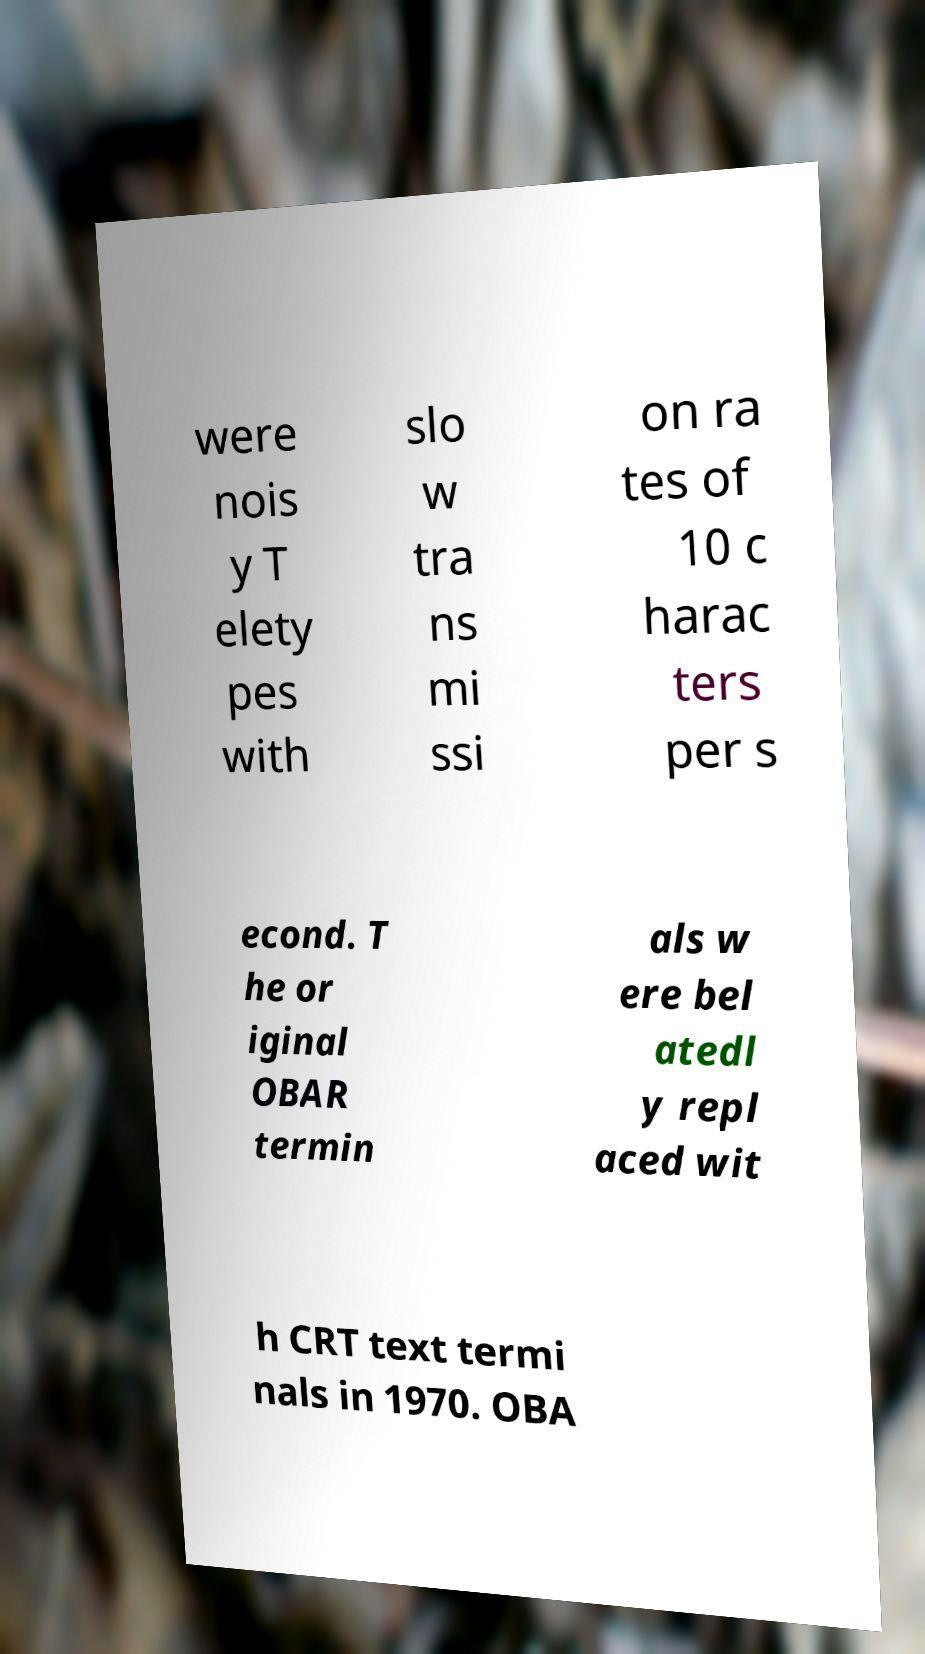There's text embedded in this image that I need extracted. Can you transcribe it verbatim? were nois y T elety pes with slo w tra ns mi ssi on ra tes of 10 c harac ters per s econd. T he or iginal OBAR termin als w ere bel atedl y repl aced wit h CRT text termi nals in 1970. OBA 